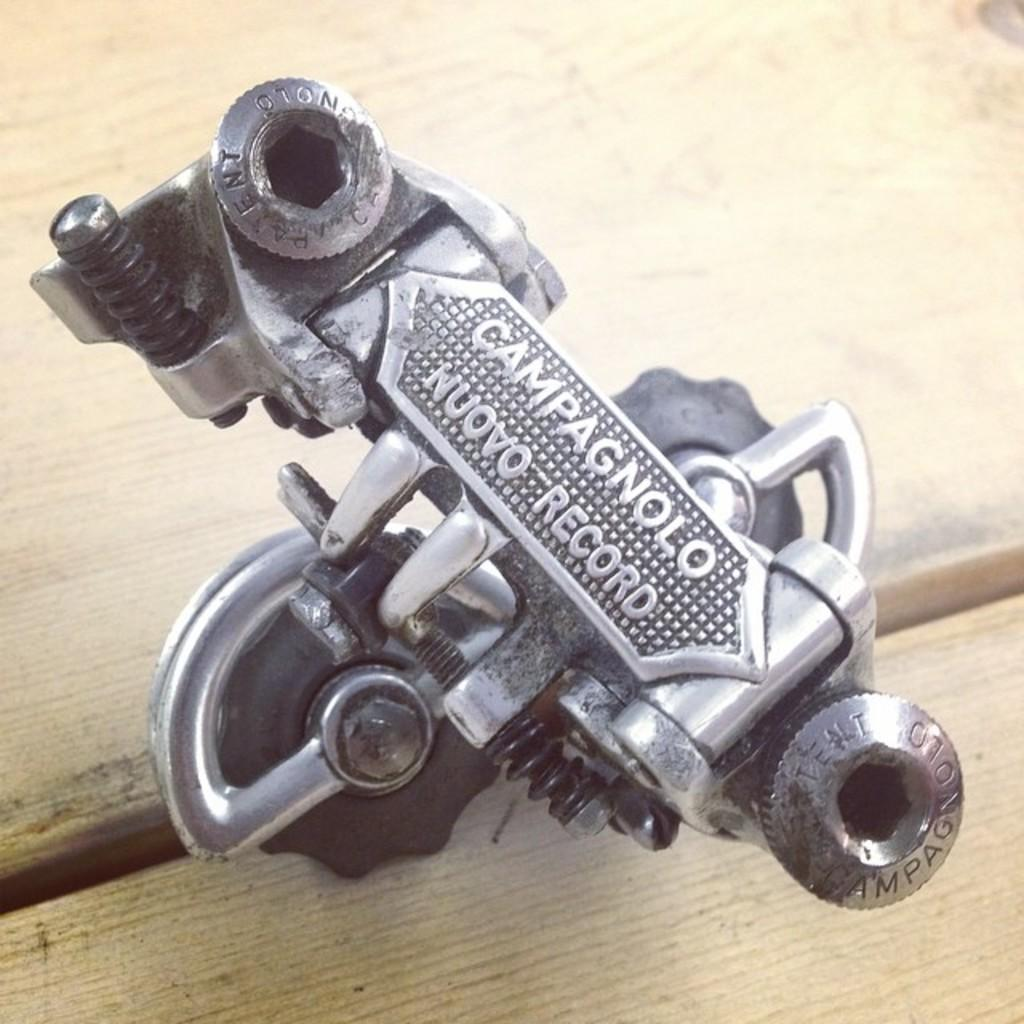What type of object is made of metal in the image? There is a metal object in the image. What can be found on the metal object? The metal object has text on it. Where is the metal object located? The metal object is on a table. What type of guitar is being played by the person in the image? There is no person or guitar present in the image; it only features a metal object with text on it. How many baseballs can be seen in the image? There are no baseballs present in the image. 